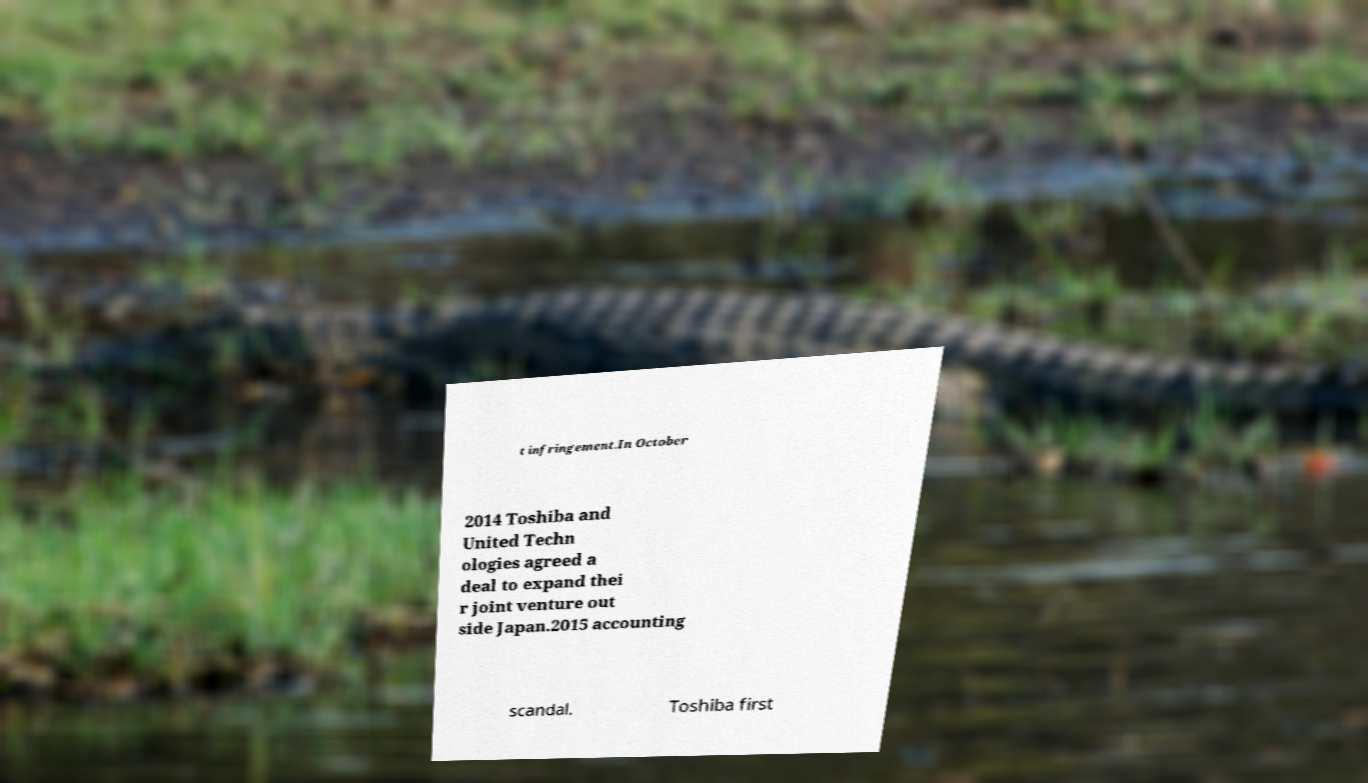Could you extract and type out the text from this image? t infringement.In October 2014 Toshiba and United Techn ologies agreed a deal to expand thei r joint venture out side Japan.2015 accounting scandal. Toshiba first 